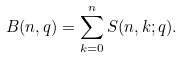Convert formula to latex. <formula><loc_0><loc_0><loc_500><loc_500>B ( n , q ) = \sum _ { k = 0 } ^ { n } S ( n , k ; q ) .</formula> 